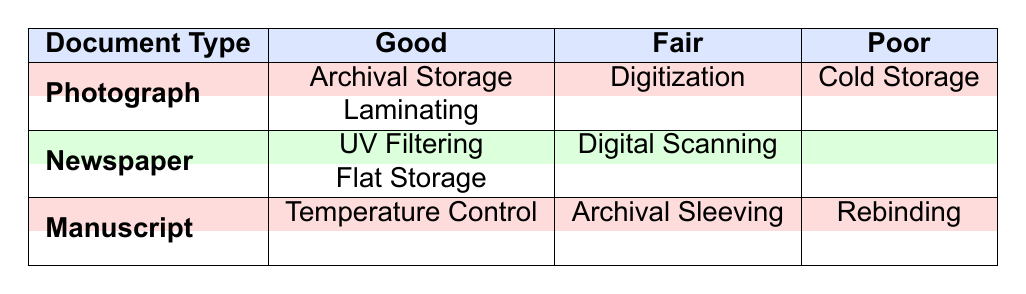What preservation methods are used for photographs in good condition? Referring to the table, there are two preservation methods listed for photographs in good condition: Archival Storage and Laminating.
Answer: Archival Storage, Laminating Is there any manuscript that is classified as poor? The table indicates that there is one manuscript listed with a poor condition, specifically associated with the preservation method Rebinding.
Answer: Yes How many different preservation methods are used for newspapers? The table shows that there are two preservation methods for newspapers in good condition (UV Filtering, Flat Storage) and one for fair condition (Digital Scanning). Since there is no entry for poor condition, the total number of unique preservation methods for newspapers is three.
Answer: 3 What are the preservation methods associated with manuscripts in fair condition? According to the table, the only preservation method for manuscripts in fair condition is Archival Sleeving.
Answer: Archival Sleeving Do any documents have both good and poor conditions listed? Examining the table reveals that each document type is only listed under one condition, meaning there are no documents that have both good and poor conditions listed simultaneously.
Answer: No Which document type has the highest variety of conditions listed? Analyzing the table, it becomes evident that both photographs and manuscripts feature three conditions (Good, Fair, Poor), while newspapers only exhibit two conditions (Good, Fair). Therefore, photographs and manuscripts have the highest variety of conditions.
Answer: Photographs, Manuscripts What preservation method is used for the photograph in poor condition? The table states that the preservation method for the photograph categorized as poor is Cold Storage.
Answer: Cold Storage What is the only preservation method used for manuscripts in poor condition? Reviewing the table, it is clear that Rebinding is the only preservation method associated with manuscripts in poor condition.
Answer: Rebinding Are any photographs documented with poor conditions preserved using Digital Scanning? The table identifies that the preservation method Digital Scanning is exclusively associated with newspapers, and thus there are no photographs in poor condition preserved using this method.
Answer: No 